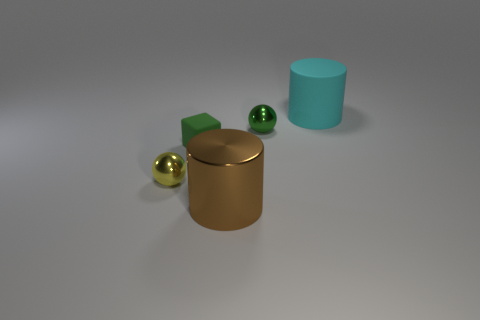Add 2 brown cylinders. How many objects exist? 7 Subtract all cylinders. How many objects are left? 3 Add 1 tiny purple metallic cubes. How many tiny purple metallic cubes exist? 1 Subtract 0 blue blocks. How many objects are left? 5 Subtract all red matte things. Subtract all yellow shiny spheres. How many objects are left? 4 Add 2 tiny green balls. How many tiny green balls are left? 3 